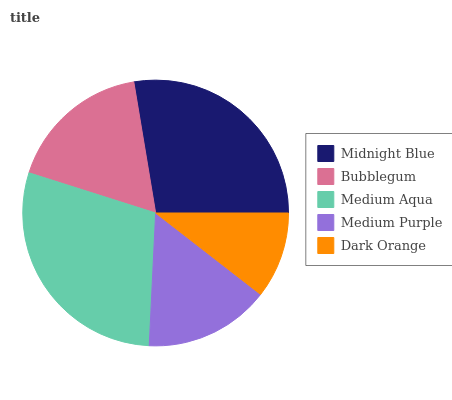Is Dark Orange the minimum?
Answer yes or no. Yes. Is Medium Aqua the maximum?
Answer yes or no. Yes. Is Bubblegum the minimum?
Answer yes or no. No. Is Bubblegum the maximum?
Answer yes or no. No. Is Midnight Blue greater than Bubblegum?
Answer yes or no. Yes. Is Bubblegum less than Midnight Blue?
Answer yes or no. Yes. Is Bubblegum greater than Midnight Blue?
Answer yes or no. No. Is Midnight Blue less than Bubblegum?
Answer yes or no. No. Is Bubblegum the high median?
Answer yes or no. Yes. Is Bubblegum the low median?
Answer yes or no. Yes. Is Midnight Blue the high median?
Answer yes or no. No. Is Medium Aqua the low median?
Answer yes or no. No. 